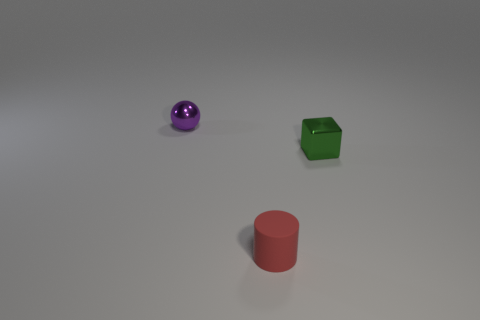Add 2 small purple things. How many objects exist? 5 Subtract all blocks. How many objects are left? 2 Subtract 0 brown cubes. How many objects are left? 3 Subtract all tiny purple shiny balls. Subtract all tiny green things. How many objects are left? 1 Add 3 green things. How many green things are left? 4 Add 2 red objects. How many red objects exist? 3 